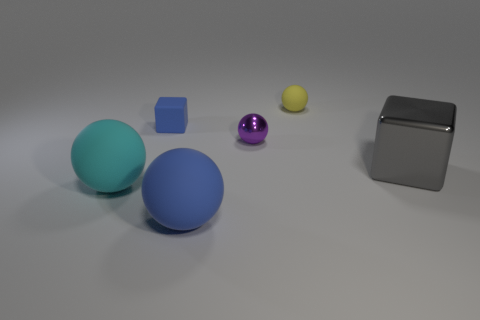How many other objects are the same size as the yellow ball?
Give a very brief answer. 2. The object that is the same color as the matte cube is what size?
Keep it short and to the point. Large. There is a object that is to the left of the tiny blue block; is its shape the same as the purple metallic object?
Keep it short and to the point. Yes. What is the blue sphere that is in front of the small blue rubber thing made of?
Give a very brief answer. Rubber. What shape is the big matte object that is the same color as the small matte cube?
Offer a very short reply. Sphere. Is there a ball made of the same material as the tiny blue object?
Provide a short and direct response. Yes. The yellow thing has what size?
Your response must be concise. Small. What number of yellow objects are big matte things or rubber balls?
Your answer should be very brief. 1. How many big blue objects are the same shape as the tiny blue matte object?
Provide a succinct answer. 0. What number of purple objects are the same size as the gray metal block?
Provide a short and direct response. 0. 